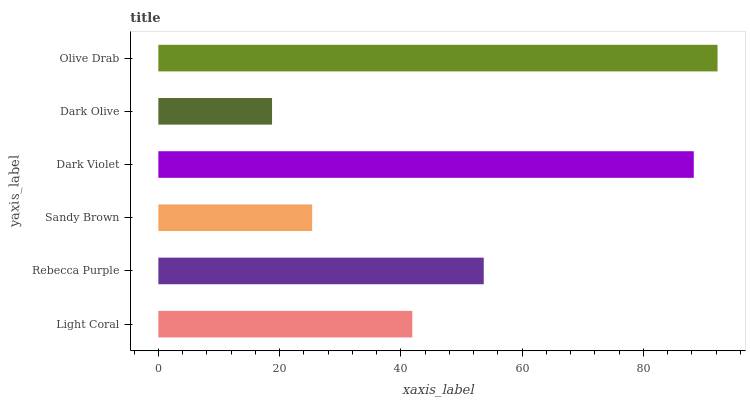Is Dark Olive the minimum?
Answer yes or no. Yes. Is Olive Drab the maximum?
Answer yes or no. Yes. Is Rebecca Purple the minimum?
Answer yes or no. No. Is Rebecca Purple the maximum?
Answer yes or no. No. Is Rebecca Purple greater than Light Coral?
Answer yes or no. Yes. Is Light Coral less than Rebecca Purple?
Answer yes or no. Yes. Is Light Coral greater than Rebecca Purple?
Answer yes or no. No. Is Rebecca Purple less than Light Coral?
Answer yes or no. No. Is Rebecca Purple the high median?
Answer yes or no. Yes. Is Light Coral the low median?
Answer yes or no. Yes. Is Light Coral the high median?
Answer yes or no. No. Is Olive Drab the low median?
Answer yes or no. No. 